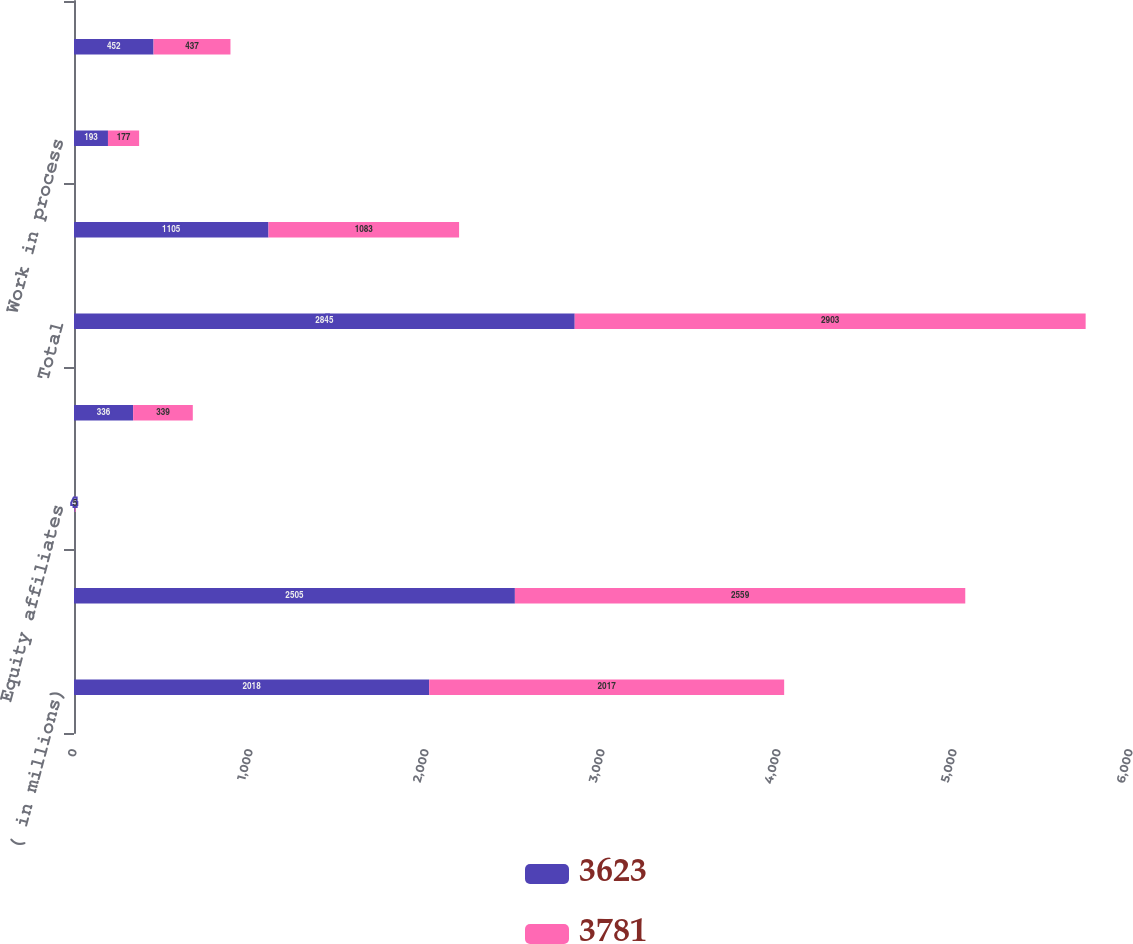Convert chart. <chart><loc_0><loc_0><loc_500><loc_500><stacked_bar_chart><ecel><fcel>( in millions)<fcel>Trade - net (1)<fcel>Equity affiliates<fcel>Other - net<fcel>Total<fcel>Finished products<fcel>Work in process<fcel>Raw materials<nl><fcel>3623<fcel>2018<fcel>2505<fcel>4<fcel>336<fcel>2845<fcel>1105<fcel>193<fcel>452<nl><fcel>3781<fcel>2017<fcel>2559<fcel>5<fcel>339<fcel>2903<fcel>1083<fcel>177<fcel>437<nl></chart> 